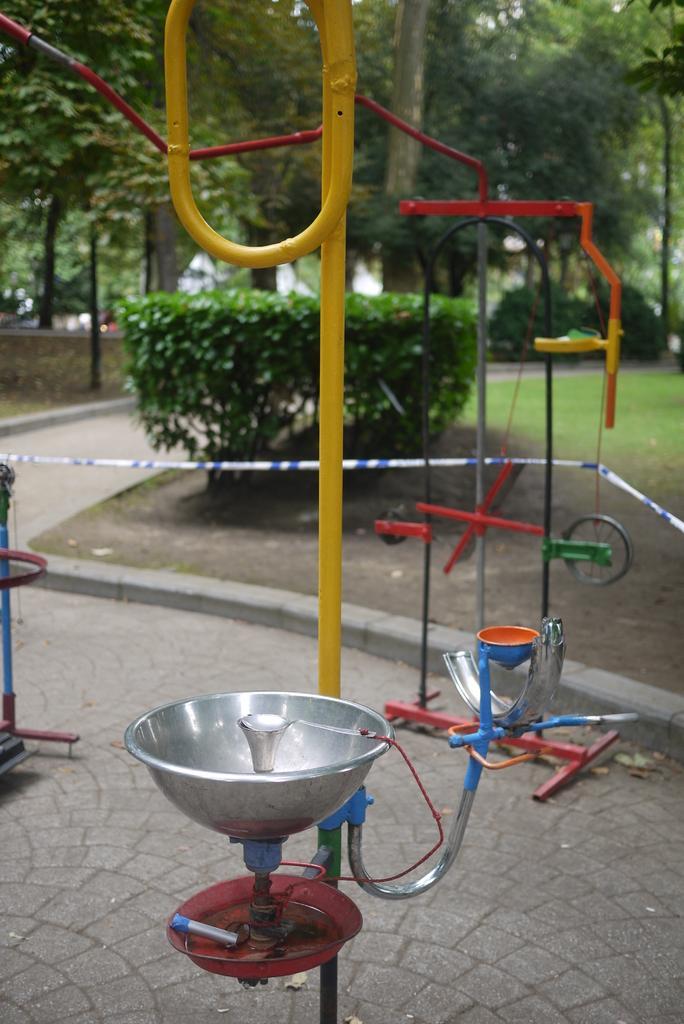Could you give a brief overview of what you see in this image? At the bottom of this image there is a metal object placed on the ground. Beside there is a pole. On the left side there is a path. In the background, I can see the grass on the ground and there are many plants and trees. 